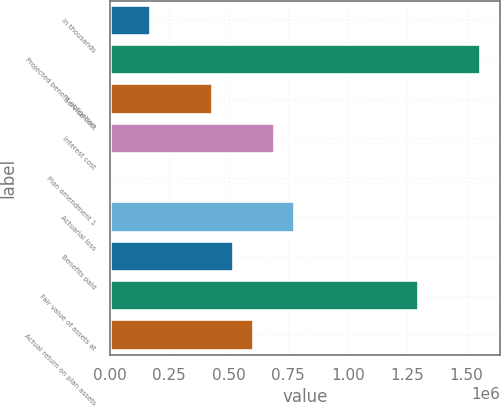<chart> <loc_0><loc_0><loc_500><loc_500><bar_chart><fcel>in thousands<fcel>Projected benefit obligation<fcel>Service cost<fcel>Interest cost<fcel>Plan amendment 1<fcel>Actuarial loss<fcel>Benefits paid<fcel>Fair value of assets at<fcel>Actual return on plan assets<nl><fcel>173478<fcel>1.56127e+06<fcel>433689<fcel>693900<fcel>4.25<fcel>780637<fcel>520426<fcel>1.30106e+06<fcel>607163<nl></chart> 